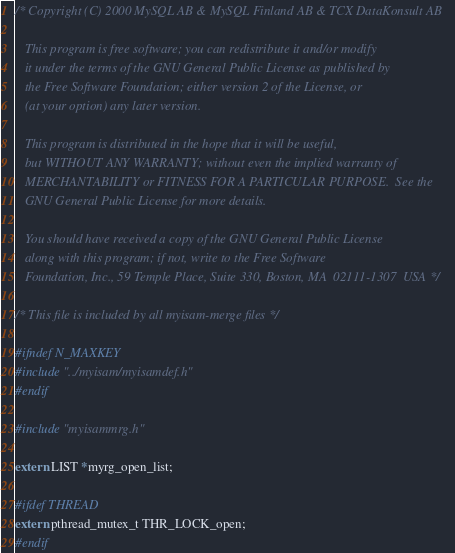<code> <loc_0><loc_0><loc_500><loc_500><_C_>/* Copyright (C) 2000 MySQL AB & MySQL Finland AB & TCX DataKonsult AB
   
   This program is free software; you can redistribute it and/or modify
   it under the terms of the GNU General Public License as published by
   the Free Software Foundation; either version 2 of the License, or
   (at your option) any later version.
   
   This program is distributed in the hope that it will be useful,
   but WITHOUT ANY WARRANTY; without even the implied warranty of
   MERCHANTABILITY or FITNESS FOR A PARTICULAR PURPOSE.  See the
   GNU General Public License for more details.
   
   You should have received a copy of the GNU General Public License
   along with this program; if not, write to the Free Software
   Foundation, Inc., 59 Temple Place, Suite 330, Boston, MA  02111-1307  USA */

/* This file is included by all myisam-merge files */

#ifndef N_MAXKEY
#include "../myisam/myisamdef.h"
#endif

#include "myisammrg.h"

extern LIST *myrg_open_list;

#ifdef THREAD
extern pthread_mutex_t THR_LOCK_open;
#endif
</code> 